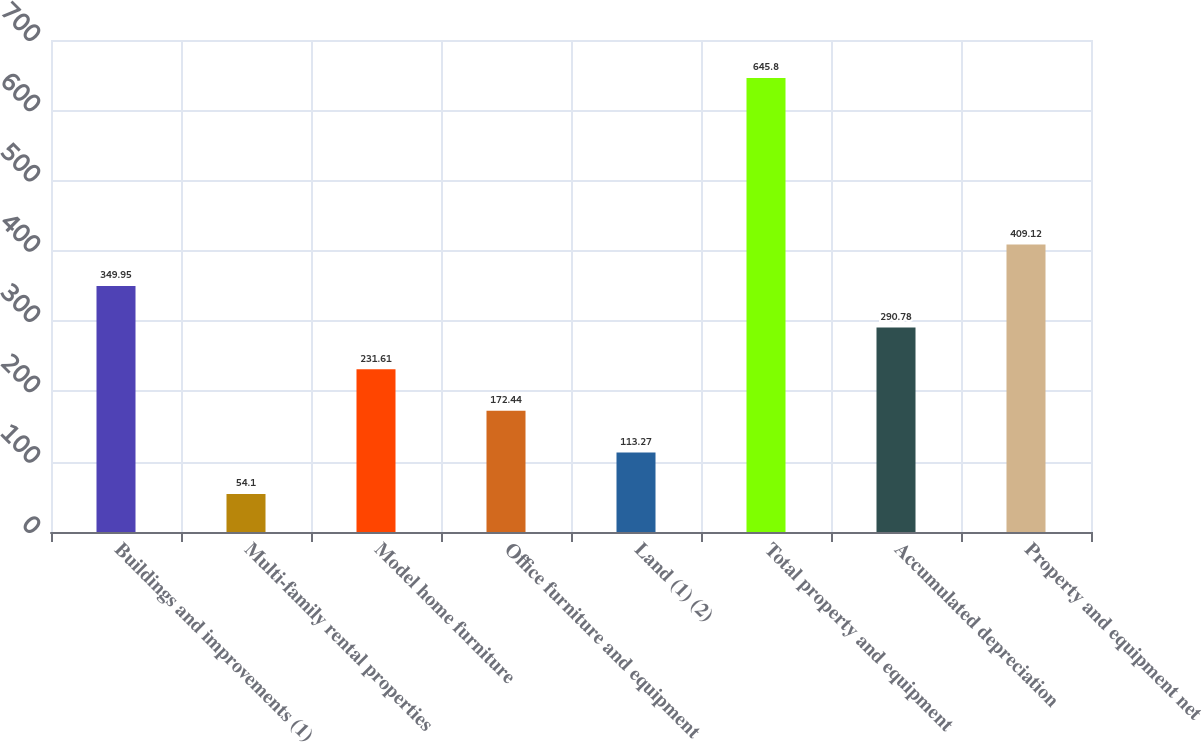Convert chart. <chart><loc_0><loc_0><loc_500><loc_500><bar_chart><fcel>Buildings and improvements (1)<fcel>Multi-family rental properties<fcel>Model home furniture<fcel>Office furniture and equipment<fcel>Land (1) (2)<fcel>Total property and equipment<fcel>Accumulated depreciation<fcel>Property and equipment net<nl><fcel>349.95<fcel>54.1<fcel>231.61<fcel>172.44<fcel>113.27<fcel>645.8<fcel>290.78<fcel>409.12<nl></chart> 